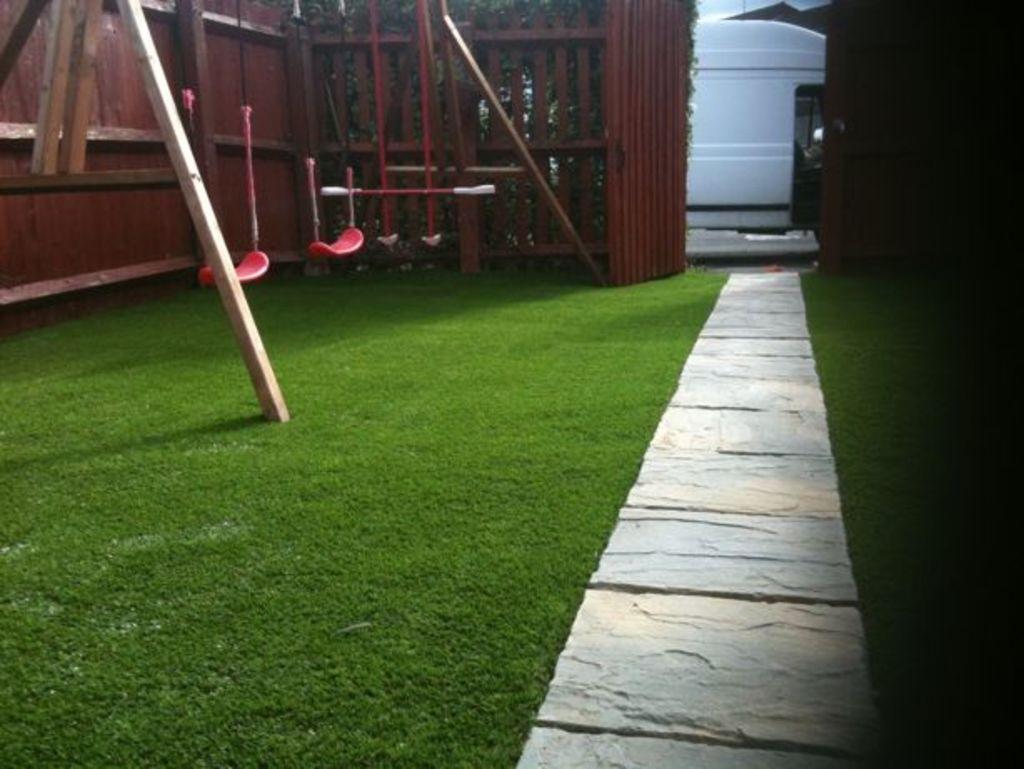Could you give a brief overview of what you see in this image? In this image we can see grassy land, pathway, swing, wooden fence and gate. Behind the gate, we can see a vehicle on the road. 